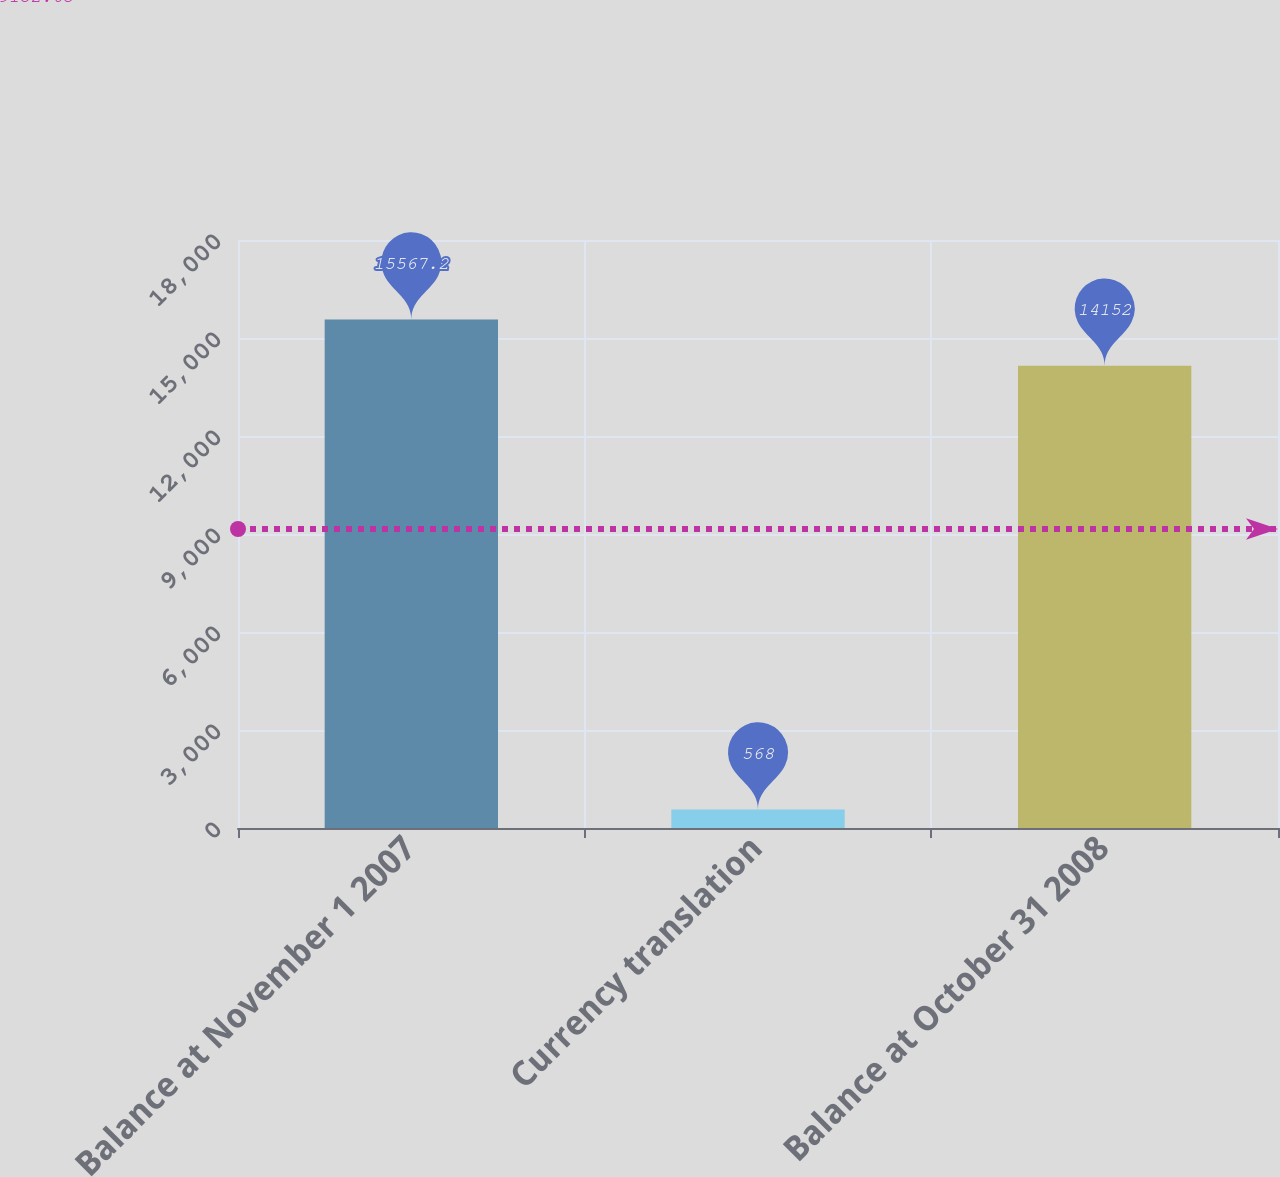Convert chart to OTSL. <chart><loc_0><loc_0><loc_500><loc_500><bar_chart><fcel>Balance at November 1 2007<fcel>Currency translation<fcel>Balance at October 31 2008<nl><fcel>15567.2<fcel>568<fcel>14152<nl></chart> 